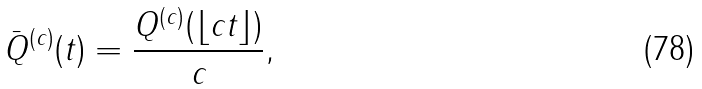<formula> <loc_0><loc_0><loc_500><loc_500>\bar { Q } ^ { ( c ) } ( t ) & = \frac { Q ^ { ( c ) } ( \lfloor c t \rfloor ) } { c } ,</formula> 